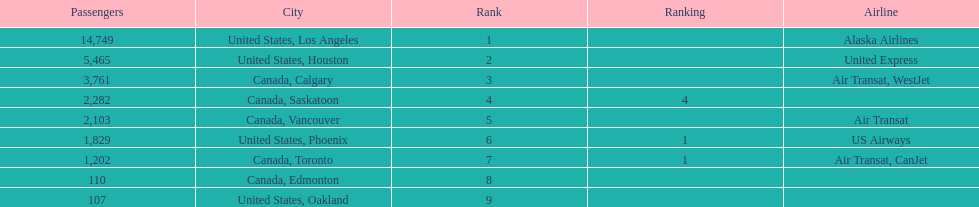Los angeles and what other city had about 19,000 passenger combined Canada, Calgary. 